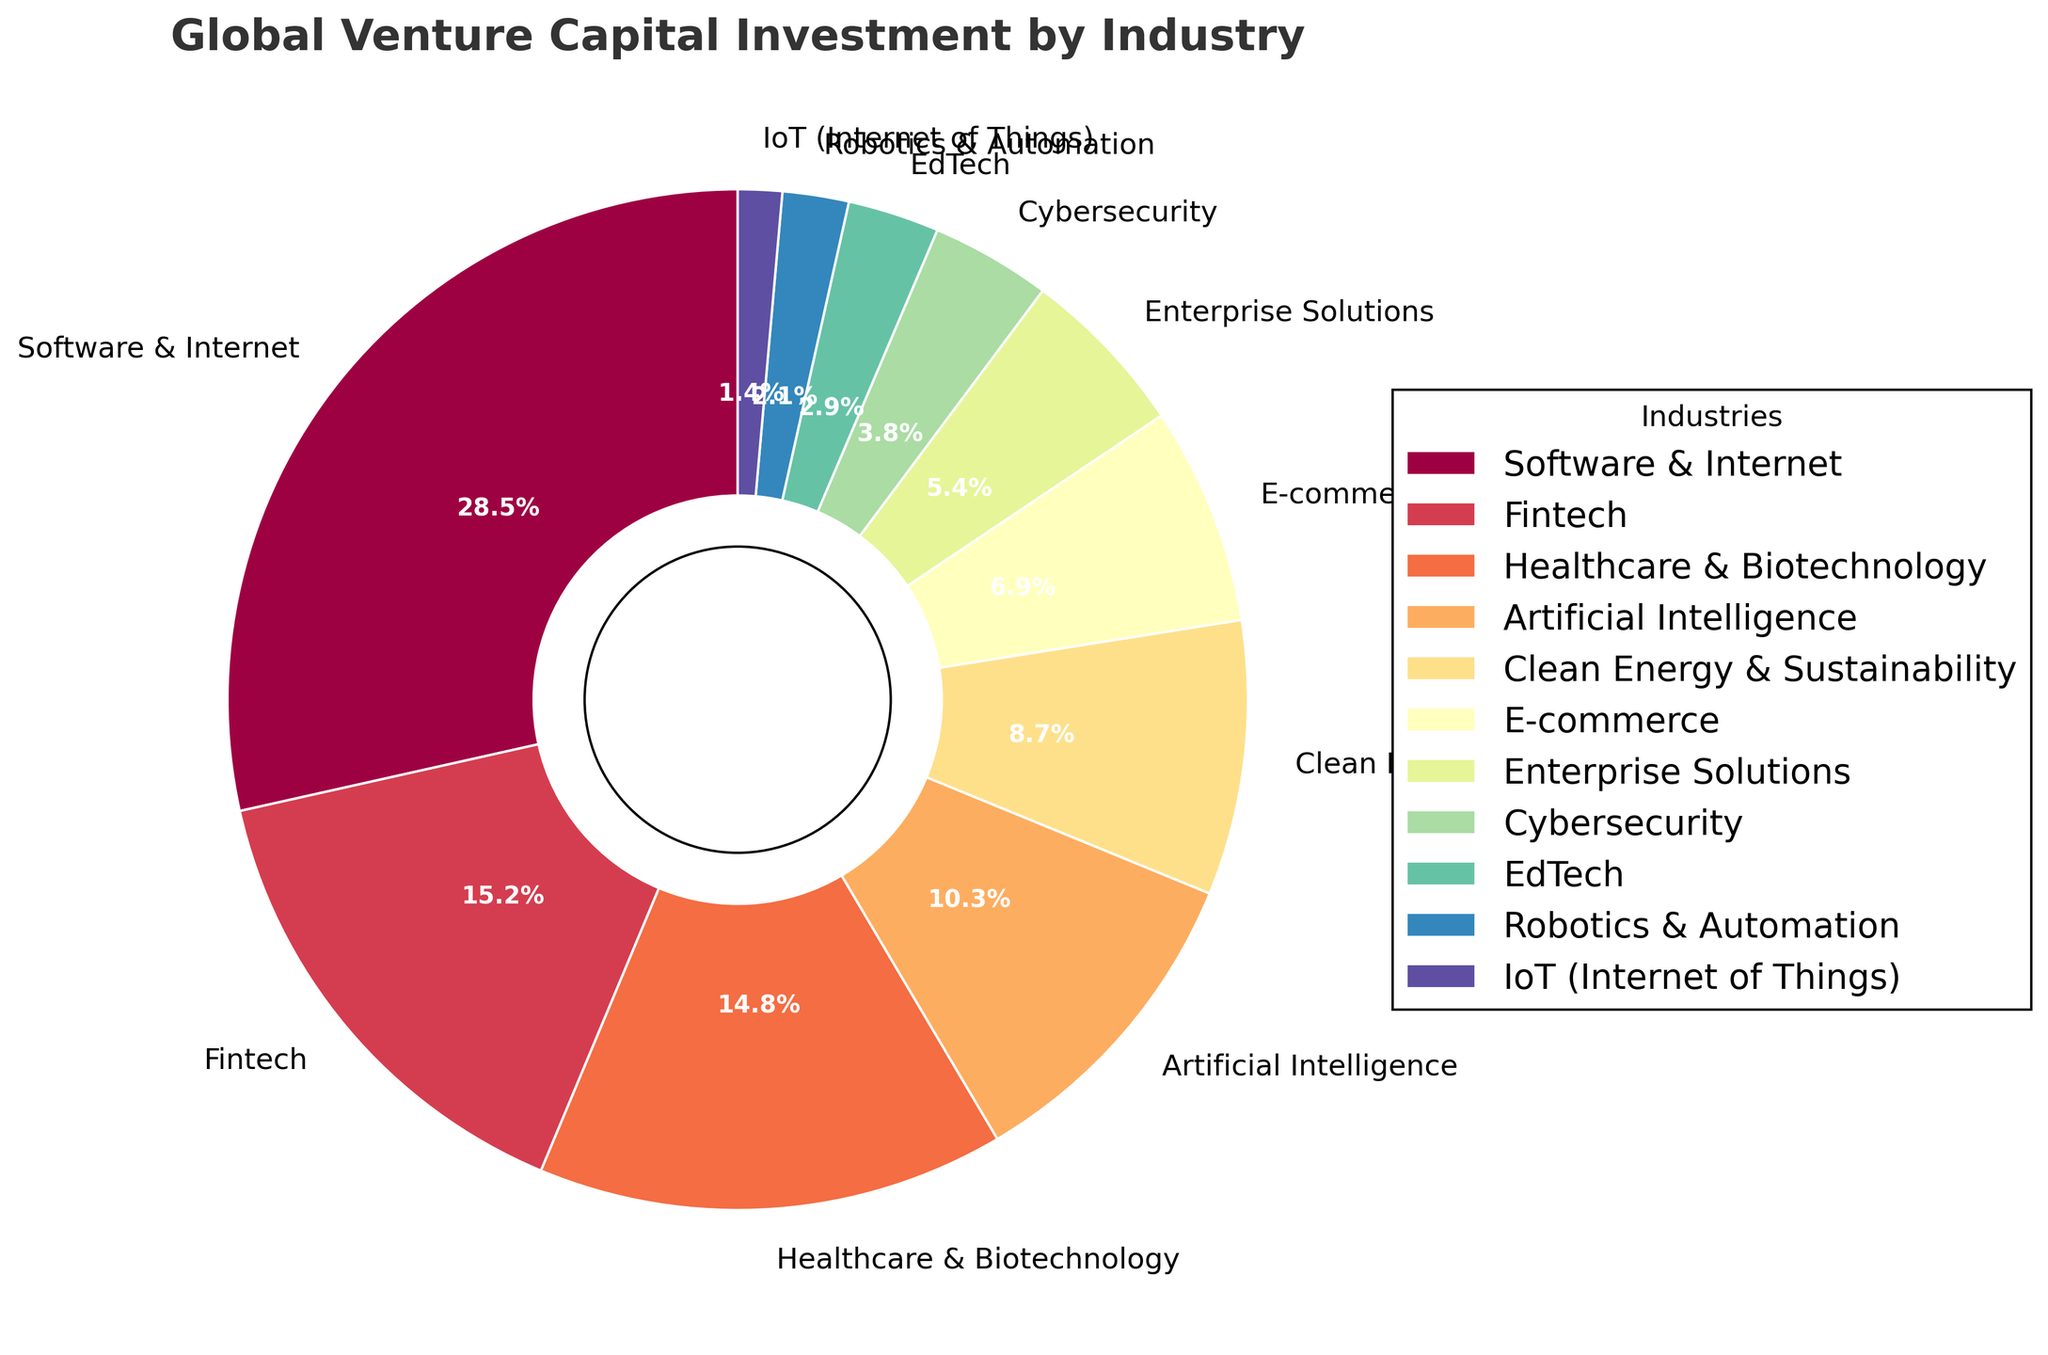Which industry received the highest percentage of global venture capital investment? The industry with the largest wedge in the pie chart represents the highest percentage of global venture capital investment.
Answer: Software & Internet What is the combined percentage of investment in Fintech and Healthcare & Biotechnology? To find the combined percentage, simply add the percentages for both industries. 15.2% (Fintech) + 14.8% (Healthcare & Biotechnology) = 30%.
Answer: 30% Which industries received less than 5% of the total venture capital investment each? Identify segments of the pie chart that represent less than 5% each. These industries are Cybersecurity (3.8%), EdTech (2.9%), Robotics & Automation (2.1%), and IoT (1.4%).
Answer: Cybersecurity, EdTech, Robotics & Automation, IoT Which industry received the smallest percentage of global venture capital investment? The smallest slice of the pie chart represents the industry with the lowest percentage.
Answer: IoT (Internet of Things) Is the investment in Artificial Intelligence higher than in Healthcare & Biotechnology? Compare the sizes of the wedges labeled Artificial Intelligence (10.3%) and Healthcare & Biotechnology (14.8%). Since 10.3% is less than 14.8%, the investment in AI is lower.
Answer: No What is the difference in investment percentages between Software & Internet and Fintech? Subtract the percentage for Fintech from the percentage for Software & Internet: 28.5% - 15.2% = 13.3%.
Answer: 13.3% Rank the industries from highest to lowest based on their percentage of global venture capital investment. List the industries in descending order according to their percentages in the pie chart: Software & Internet (28.5%), Fintech (15.2%), Healthcare & Biotechnology (14.8%), Artificial Intelligence (10.3%), Clean Energy & Sustainability (8.7%), E-commerce (6.9%), Enterprise Solutions (5.4%), Cybersecurity (3.8%), EdTech (2.9%), Robotics & Automation (2.1%), IoT (1.4%).
Answer: Software & Internet, Fintech, Healthcare & Biotechnology, Artificial Intelligence, Clean Energy & Sustainability, E-commerce, Enterprise Solutions, Cybersecurity, EdTech, Robotics & Automation, IoT What portion of the pie chart is occupied by industries related to technology (Software & Internet, Artificial Intelligence, and IoT)? Add the percentages for Software & Internet (28.5%), Artificial Intelligence (10.3%), and IoT (1.4%): 28.5% + 10.3% + 1.4% = 40.2%.
Answer: 40.2% 